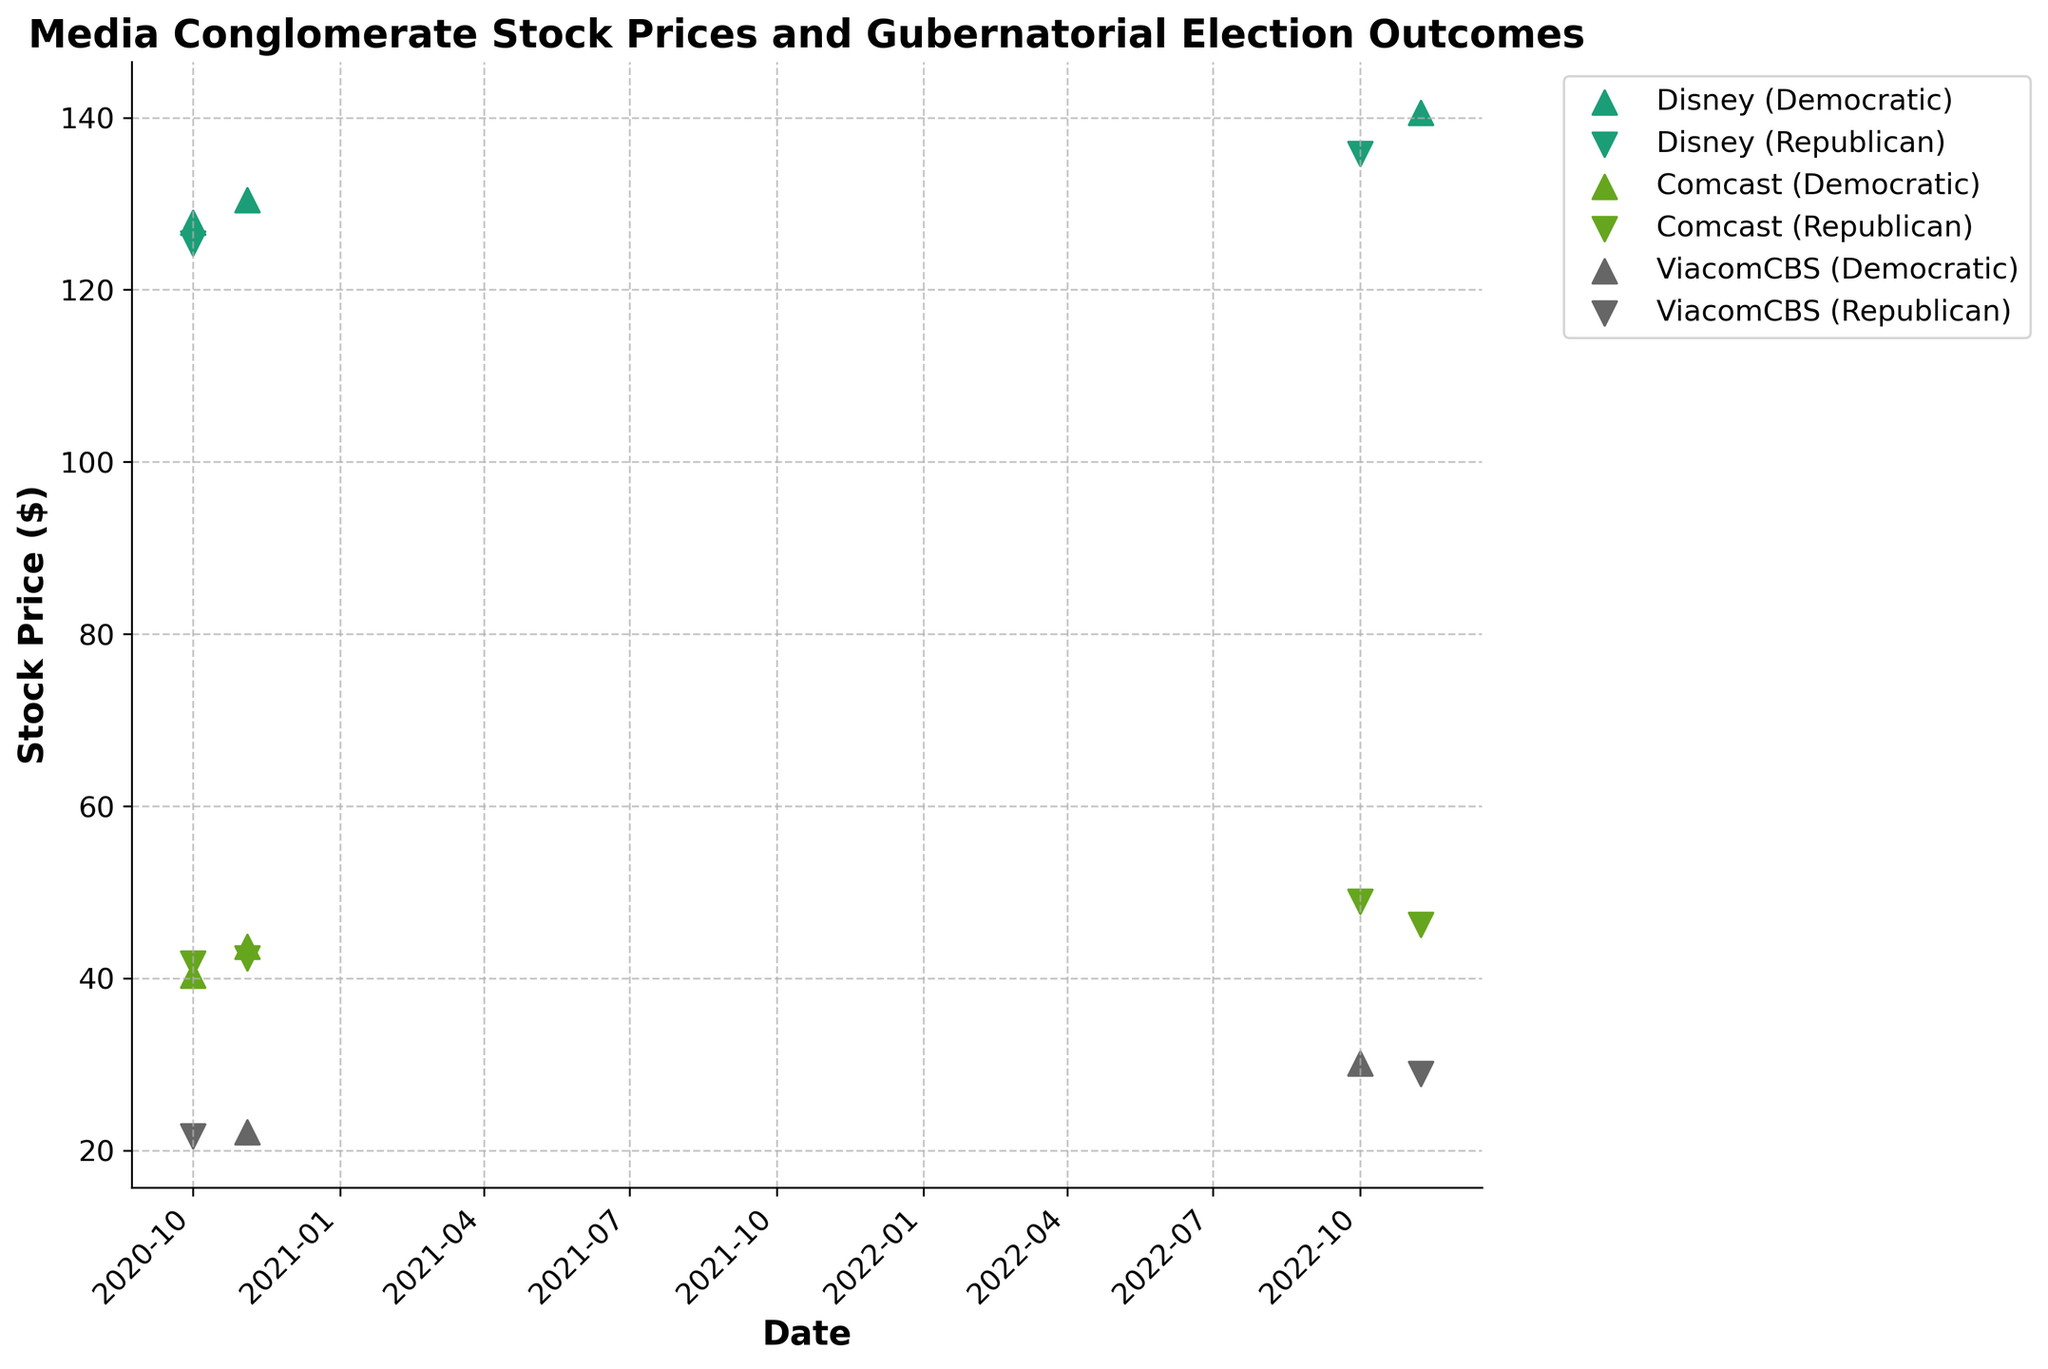What is the title of the plot? The title is written at the top of the plot, indicating the subject of the figure. It helps viewers quickly understand what the plot is about. The title is "Media Conglomerate Stock Prices and Gubernatorial Election Outcomes"
Answer: Media Conglomerate Stock Prices and Gubernatorial Election Outcomes How are the stock prices of Disney affected by Democratic gubernatorial election outcomes? To answer this question, look for the triangles (indicating Democratic outcomes) corresponding to Disney across different dates and note the stock prices.
Answer: The stock prices of Disney on Democratic outcomes are higher compared to some other points Which company had the highest stock price on November 8, 2022? By looking at the stock prices for each company on the specific date of November 8, 2022, you can identify the highest value. The data points are marked, making it relatively straightforward to compare.
Answer: Disney What is the general trend in Comcast’s stock price from October 1, 2020, to November 8, 2022? To identify the trend, follow the Comcast data points from the earliest to the latest date. Determine if the overall direction is increasing, decreasing, or stable.
Answer: Increasing Compare the stock prices of ViacomCBS under Republican and Democratic gubernatorial election outcomes. Look at the markers for ViacomCBS with triangles for Democratic and inverted triangles for Republican outcomes. Compare the stock prices shown by these markers.
Answer: ViacomCBS stock prices were higher under Democratic outcomes What is the average stock price of Comcast during Republican gubernatorial election outcomes? Identify all the Comcast data points marked with inverted triangles (Republican outcomes) and compute the average of these stock prices.
Answer: Average = (40.29 + 42.31 + 48.90 + 46.20) / 4 = 44.425 What is the difference in Disney’s stock price between October 1, 2020, and November 8, 2022, under Democratic gubernatorial election outcomes? Identify Disney’s stock prices on the specified dates under Democratic outcomes, then calculate the difference.
Answer: Difference = 140.55 (Nov 8, 2022) - 127.80 (Oct 1, 2020) = 12.75 Which company's stock price fluctuated the most between the two major election outcome categories? Compare the range of stock prices for each company under Democratic and Republican outcomes separately and find the company with the maximum fluctuation.
Answer: Comcast How does the stock price variance of ViacomCBS differ under Democratic and Republican gubernatorial election outcomes? Calculate the variance for ViacomCBS stock prices under each election outcome category to determine the extent of variability.
Answer: Variance is higher under Democratic outcomes Are there any companies for which the stock price is relatively unaffected by gubernatorial election outcomes? Examine the stock prices for each company across both Democratic and Republican outcomes to see if any company's prices remain relatively stable.
Answer: No consistent pattern shows neutrality; all companies display some fluctuation 